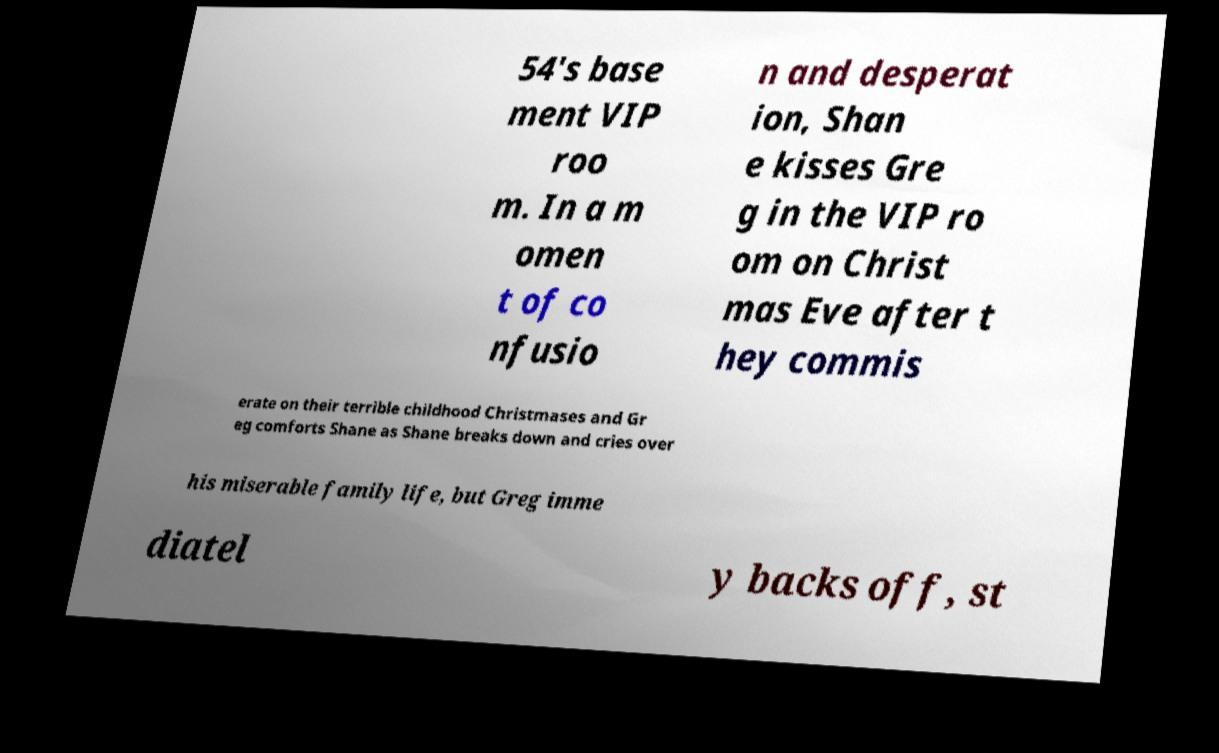For documentation purposes, I need the text within this image transcribed. Could you provide that? 54's base ment VIP roo m. In a m omen t of co nfusio n and desperat ion, Shan e kisses Gre g in the VIP ro om on Christ mas Eve after t hey commis erate on their terrible childhood Christmases and Gr eg comforts Shane as Shane breaks down and cries over his miserable family life, but Greg imme diatel y backs off, st 